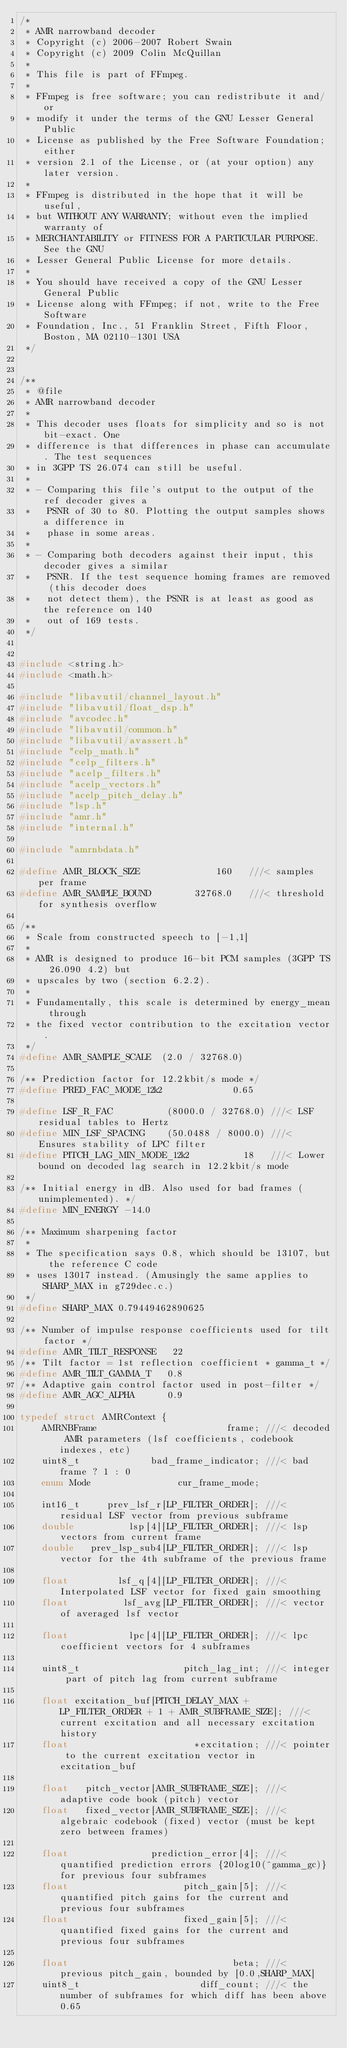<code> <loc_0><loc_0><loc_500><loc_500><_C_>/*
 * AMR narrowband decoder
 * Copyright (c) 2006-2007 Robert Swain
 * Copyright (c) 2009 Colin McQuillan
 *
 * This file is part of FFmpeg.
 *
 * FFmpeg is free software; you can redistribute it and/or
 * modify it under the terms of the GNU Lesser General Public
 * License as published by the Free Software Foundation; either
 * version 2.1 of the License, or (at your option) any later version.
 *
 * FFmpeg is distributed in the hope that it will be useful,
 * but WITHOUT ANY WARRANTY; without even the implied warranty of
 * MERCHANTABILITY or FITNESS FOR A PARTICULAR PURPOSE.  See the GNU
 * Lesser General Public License for more details.
 *
 * You should have received a copy of the GNU Lesser General Public
 * License along with FFmpeg; if not, write to the Free Software
 * Foundation, Inc., 51 Franklin Street, Fifth Floor, Boston, MA 02110-1301 USA
 */


/**
 * @file
 * AMR narrowband decoder
 *
 * This decoder uses floats for simplicity and so is not bit-exact. One
 * difference is that differences in phase can accumulate. The test sequences
 * in 3GPP TS 26.074 can still be useful.
 *
 * - Comparing this file's output to the output of the ref decoder gives a
 *   PSNR of 30 to 80. Plotting the output samples shows a difference in
 *   phase in some areas.
 *
 * - Comparing both decoders against their input, this decoder gives a similar
 *   PSNR. If the test sequence homing frames are removed (this decoder does
 *   not detect them), the PSNR is at least as good as the reference on 140
 *   out of 169 tests.
 */


#include <string.h>
#include <math.h>

#include "libavutil/channel_layout.h"
#include "libavutil/float_dsp.h"
#include "avcodec.h"
#include "libavutil/common.h"
#include "libavutil/avassert.h"
#include "celp_math.h"
#include "celp_filters.h"
#include "acelp_filters.h"
#include "acelp_vectors.h"
#include "acelp_pitch_delay.h"
#include "lsp.h"
#include "amr.h"
#include "internal.h"

#include "amrnbdata.h"

#define AMR_BLOCK_SIZE              160   ///< samples per frame
#define AMR_SAMPLE_BOUND        32768.0   ///< threshold for synthesis overflow

/**
 * Scale from constructed speech to [-1,1]
 *
 * AMR is designed to produce 16-bit PCM samples (3GPP TS 26.090 4.2) but
 * upscales by two (section 6.2.2).
 *
 * Fundamentally, this scale is determined by energy_mean through
 * the fixed vector contribution to the excitation vector.
 */
#define AMR_SAMPLE_SCALE  (2.0 / 32768.0)

/** Prediction factor for 12.2kbit/s mode */
#define PRED_FAC_MODE_12k2             0.65

#define LSF_R_FAC          (8000.0 / 32768.0) ///< LSF residual tables to Hertz
#define MIN_LSF_SPACING    (50.0488 / 8000.0) ///< Ensures stability of LPC filter
#define PITCH_LAG_MIN_MODE_12k2          18   ///< Lower bound on decoded lag search in 12.2kbit/s mode

/** Initial energy in dB. Also used for bad frames (unimplemented). */
#define MIN_ENERGY -14.0

/** Maximum sharpening factor
 *
 * The specification says 0.8, which should be 13107, but the reference C code
 * uses 13017 instead. (Amusingly the same applies to SHARP_MAX in g729dec.c.)
 */
#define SHARP_MAX 0.79449462890625

/** Number of impulse response coefficients used for tilt factor */
#define AMR_TILT_RESPONSE   22
/** Tilt factor = 1st reflection coefficient * gamma_t */
#define AMR_TILT_GAMMA_T   0.8
/** Adaptive gain control factor used in post-filter */
#define AMR_AGC_ALPHA      0.9

typedef struct AMRContext {
    AMRNBFrame                        frame; ///< decoded AMR parameters (lsf coefficients, codebook indexes, etc)
    uint8_t             bad_frame_indicator; ///< bad frame ? 1 : 0
    enum Mode                cur_frame_mode;

    int16_t     prev_lsf_r[LP_FILTER_ORDER]; ///< residual LSF vector from previous subframe
    double          lsp[4][LP_FILTER_ORDER]; ///< lsp vectors from current frame
    double   prev_lsp_sub4[LP_FILTER_ORDER]; ///< lsp vector for the 4th subframe of the previous frame

    float         lsf_q[4][LP_FILTER_ORDER]; ///< Interpolated LSF vector for fixed gain smoothing
    float          lsf_avg[LP_FILTER_ORDER]; ///< vector of averaged lsf vector

    float           lpc[4][LP_FILTER_ORDER]; ///< lpc coefficient vectors for 4 subframes

    uint8_t                   pitch_lag_int; ///< integer part of pitch lag from current subframe

    float excitation_buf[PITCH_DELAY_MAX + LP_FILTER_ORDER + 1 + AMR_SUBFRAME_SIZE]; ///< current excitation and all necessary excitation history
    float                       *excitation; ///< pointer to the current excitation vector in excitation_buf

    float   pitch_vector[AMR_SUBFRAME_SIZE]; ///< adaptive code book (pitch) vector
    float   fixed_vector[AMR_SUBFRAME_SIZE]; ///< algebraic codebook (fixed) vector (must be kept zero between frames)

    float               prediction_error[4]; ///< quantified prediction errors {20log10(^gamma_gc)} for previous four subframes
    float                     pitch_gain[5]; ///< quantified pitch gains for the current and previous four subframes
    float                     fixed_gain[5]; ///< quantified fixed gains for the current and previous four subframes

    float                              beta; ///< previous pitch_gain, bounded by [0.0,SHARP_MAX]
    uint8_t                      diff_count; ///< the number of subframes for which diff has been above 0.65</code> 